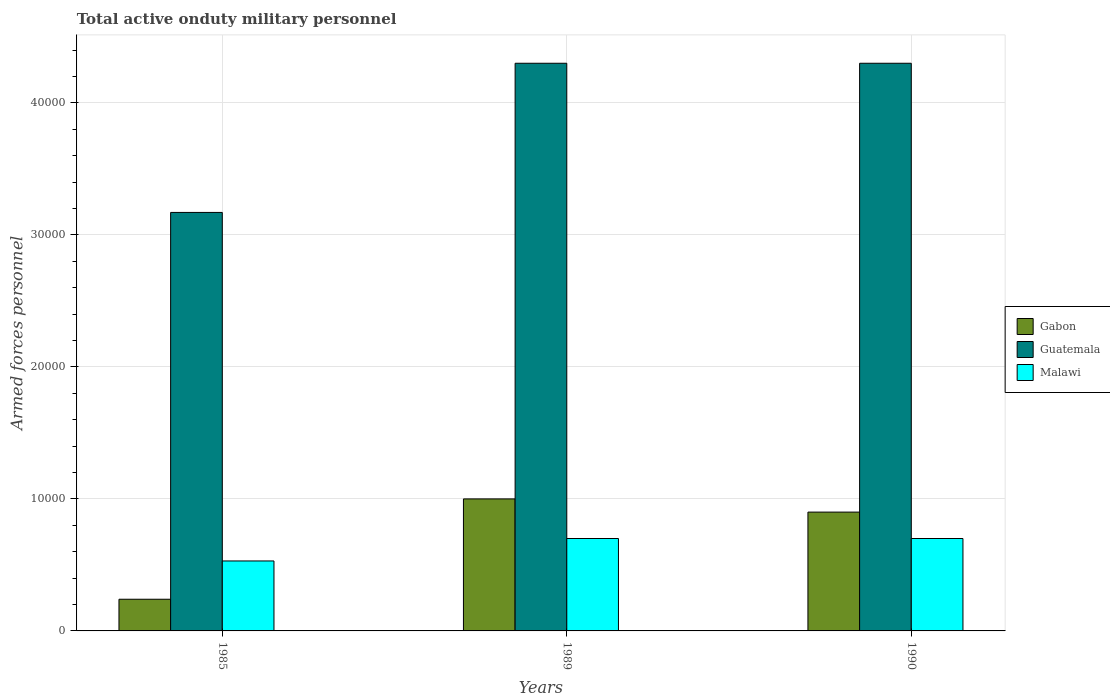How many different coloured bars are there?
Give a very brief answer. 3. How many groups of bars are there?
Offer a very short reply. 3. Are the number of bars per tick equal to the number of legend labels?
Offer a very short reply. Yes. In how many cases, is the number of bars for a given year not equal to the number of legend labels?
Provide a succinct answer. 0. What is the number of armed forces personnel in Gabon in 1990?
Your response must be concise. 9000. Across all years, what is the minimum number of armed forces personnel in Guatemala?
Your answer should be very brief. 3.17e+04. What is the total number of armed forces personnel in Guatemala in the graph?
Make the answer very short. 1.18e+05. What is the difference between the number of armed forces personnel in Malawi in 1985 and that in 1989?
Give a very brief answer. -1700. What is the difference between the number of armed forces personnel in Malawi in 1989 and the number of armed forces personnel in Guatemala in 1990?
Your answer should be compact. -3.60e+04. What is the average number of armed forces personnel in Guatemala per year?
Offer a very short reply. 3.92e+04. In the year 1989, what is the difference between the number of armed forces personnel in Gabon and number of armed forces personnel in Malawi?
Your response must be concise. 3000. What is the ratio of the number of armed forces personnel in Gabon in 1985 to that in 1989?
Offer a terse response. 0.24. Is the difference between the number of armed forces personnel in Gabon in 1989 and 1990 greater than the difference between the number of armed forces personnel in Malawi in 1989 and 1990?
Your answer should be compact. Yes. What is the difference between the highest and the lowest number of armed forces personnel in Gabon?
Offer a very short reply. 7600. Is the sum of the number of armed forces personnel in Malawi in 1985 and 1989 greater than the maximum number of armed forces personnel in Gabon across all years?
Offer a very short reply. Yes. What does the 2nd bar from the left in 1989 represents?
Ensure brevity in your answer.  Guatemala. What does the 1st bar from the right in 1989 represents?
Provide a succinct answer. Malawi. Is it the case that in every year, the sum of the number of armed forces personnel in Guatemala and number of armed forces personnel in Malawi is greater than the number of armed forces personnel in Gabon?
Offer a very short reply. Yes. Are all the bars in the graph horizontal?
Give a very brief answer. No. How many years are there in the graph?
Keep it short and to the point. 3. Are the values on the major ticks of Y-axis written in scientific E-notation?
Ensure brevity in your answer.  No. What is the title of the graph?
Offer a terse response. Total active onduty military personnel. What is the label or title of the X-axis?
Your answer should be compact. Years. What is the label or title of the Y-axis?
Provide a succinct answer. Armed forces personnel. What is the Armed forces personnel in Gabon in 1985?
Your answer should be compact. 2400. What is the Armed forces personnel in Guatemala in 1985?
Keep it short and to the point. 3.17e+04. What is the Armed forces personnel of Malawi in 1985?
Your answer should be compact. 5300. What is the Armed forces personnel in Guatemala in 1989?
Ensure brevity in your answer.  4.30e+04. What is the Armed forces personnel of Malawi in 1989?
Provide a short and direct response. 7000. What is the Armed forces personnel in Gabon in 1990?
Provide a short and direct response. 9000. What is the Armed forces personnel in Guatemala in 1990?
Your response must be concise. 4.30e+04. What is the Armed forces personnel of Malawi in 1990?
Your response must be concise. 7000. Across all years, what is the maximum Armed forces personnel in Guatemala?
Keep it short and to the point. 4.30e+04. Across all years, what is the maximum Armed forces personnel of Malawi?
Give a very brief answer. 7000. Across all years, what is the minimum Armed forces personnel of Gabon?
Make the answer very short. 2400. Across all years, what is the minimum Armed forces personnel of Guatemala?
Offer a terse response. 3.17e+04. Across all years, what is the minimum Armed forces personnel in Malawi?
Offer a very short reply. 5300. What is the total Armed forces personnel of Gabon in the graph?
Ensure brevity in your answer.  2.14e+04. What is the total Armed forces personnel in Guatemala in the graph?
Your answer should be compact. 1.18e+05. What is the total Armed forces personnel in Malawi in the graph?
Provide a succinct answer. 1.93e+04. What is the difference between the Armed forces personnel in Gabon in 1985 and that in 1989?
Give a very brief answer. -7600. What is the difference between the Armed forces personnel of Guatemala in 1985 and that in 1989?
Your answer should be very brief. -1.13e+04. What is the difference between the Armed forces personnel of Malawi in 1985 and that in 1989?
Provide a short and direct response. -1700. What is the difference between the Armed forces personnel in Gabon in 1985 and that in 1990?
Make the answer very short. -6600. What is the difference between the Armed forces personnel of Guatemala in 1985 and that in 1990?
Give a very brief answer. -1.13e+04. What is the difference between the Armed forces personnel of Malawi in 1985 and that in 1990?
Your answer should be compact. -1700. What is the difference between the Armed forces personnel in Guatemala in 1989 and that in 1990?
Provide a short and direct response. 0. What is the difference between the Armed forces personnel of Gabon in 1985 and the Armed forces personnel of Guatemala in 1989?
Ensure brevity in your answer.  -4.06e+04. What is the difference between the Armed forces personnel in Gabon in 1985 and the Armed forces personnel in Malawi in 1989?
Offer a terse response. -4600. What is the difference between the Armed forces personnel in Guatemala in 1985 and the Armed forces personnel in Malawi in 1989?
Provide a short and direct response. 2.47e+04. What is the difference between the Armed forces personnel in Gabon in 1985 and the Armed forces personnel in Guatemala in 1990?
Provide a succinct answer. -4.06e+04. What is the difference between the Armed forces personnel of Gabon in 1985 and the Armed forces personnel of Malawi in 1990?
Offer a terse response. -4600. What is the difference between the Armed forces personnel in Guatemala in 1985 and the Armed forces personnel in Malawi in 1990?
Offer a very short reply. 2.47e+04. What is the difference between the Armed forces personnel in Gabon in 1989 and the Armed forces personnel in Guatemala in 1990?
Your response must be concise. -3.30e+04. What is the difference between the Armed forces personnel in Gabon in 1989 and the Armed forces personnel in Malawi in 1990?
Ensure brevity in your answer.  3000. What is the difference between the Armed forces personnel in Guatemala in 1989 and the Armed forces personnel in Malawi in 1990?
Ensure brevity in your answer.  3.60e+04. What is the average Armed forces personnel in Gabon per year?
Your response must be concise. 7133.33. What is the average Armed forces personnel of Guatemala per year?
Make the answer very short. 3.92e+04. What is the average Armed forces personnel in Malawi per year?
Your answer should be very brief. 6433.33. In the year 1985, what is the difference between the Armed forces personnel in Gabon and Armed forces personnel in Guatemala?
Your answer should be compact. -2.93e+04. In the year 1985, what is the difference between the Armed forces personnel of Gabon and Armed forces personnel of Malawi?
Your answer should be very brief. -2900. In the year 1985, what is the difference between the Armed forces personnel of Guatemala and Armed forces personnel of Malawi?
Provide a short and direct response. 2.64e+04. In the year 1989, what is the difference between the Armed forces personnel in Gabon and Armed forces personnel in Guatemala?
Provide a succinct answer. -3.30e+04. In the year 1989, what is the difference between the Armed forces personnel in Gabon and Armed forces personnel in Malawi?
Provide a short and direct response. 3000. In the year 1989, what is the difference between the Armed forces personnel of Guatemala and Armed forces personnel of Malawi?
Provide a short and direct response. 3.60e+04. In the year 1990, what is the difference between the Armed forces personnel of Gabon and Armed forces personnel of Guatemala?
Your answer should be compact. -3.40e+04. In the year 1990, what is the difference between the Armed forces personnel of Gabon and Armed forces personnel of Malawi?
Provide a succinct answer. 2000. In the year 1990, what is the difference between the Armed forces personnel in Guatemala and Armed forces personnel in Malawi?
Give a very brief answer. 3.60e+04. What is the ratio of the Armed forces personnel in Gabon in 1985 to that in 1989?
Your response must be concise. 0.24. What is the ratio of the Armed forces personnel in Guatemala in 1985 to that in 1989?
Offer a terse response. 0.74. What is the ratio of the Armed forces personnel of Malawi in 1985 to that in 1989?
Your answer should be very brief. 0.76. What is the ratio of the Armed forces personnel in Gabon in 1985 to that in 1990?
Your answer should be very brief. 0.27. What is the ratio of the Armed forces personnel of Guatemala in 1985 to that in 1990?
Offer a terse response. 0.74. What is the ratio of the Armed forces personnel in Malawi in 1985 to that in 1990?
Make the answer very short. 0.76. What is the difference between the highest and the lowest Armed forces personnel of Gabon?
Offer a very short reply. 7600. What is the difference between the highest and the lowest Armed forces personnel in Guatemala?
Your answer should be compact. 1.13e+04. What is the difference between the highest and the lowest Armed forces personnel in Malawi?
Offer a very short reply. 1700. 